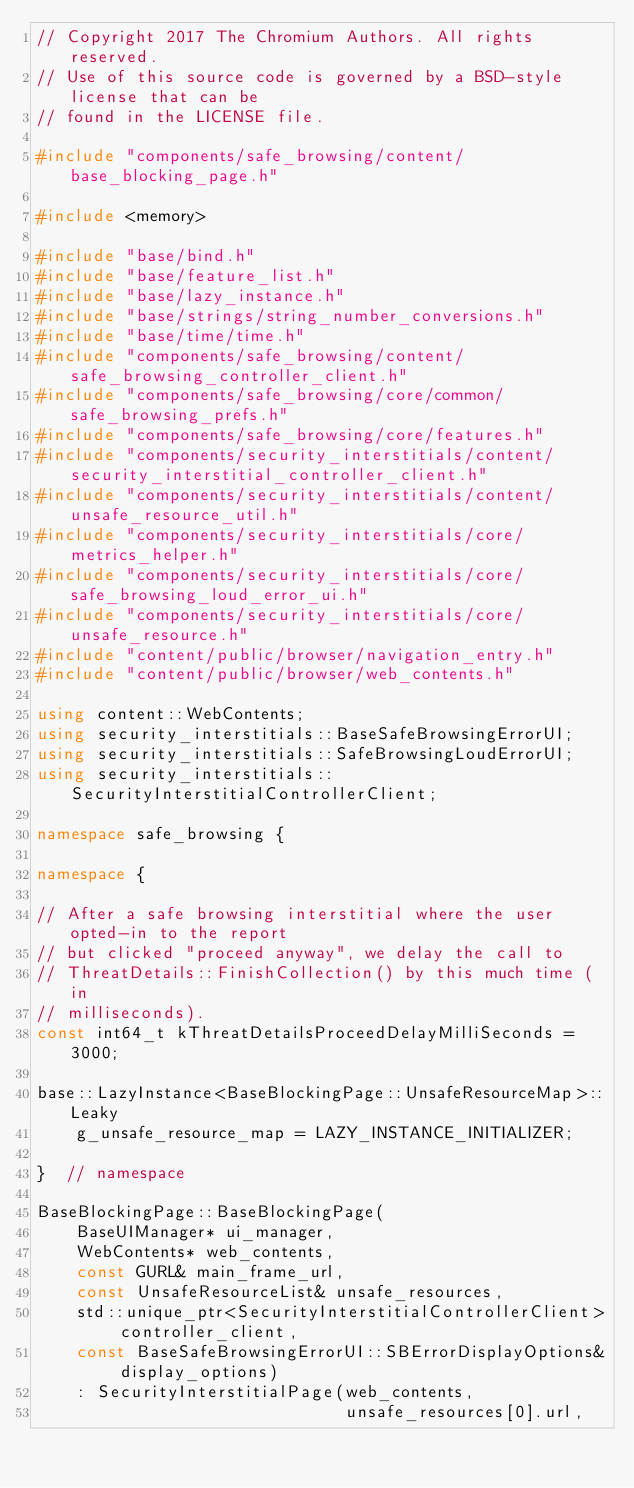Convert code to text. <code><loc_0><loc_0><loc_500><loc_500><_C++_>// Copyright 2017 The Chromium Authors. All rights reserved.
// Use of this source code is governed by a BSD-style license that can be
// found in the LICENSE file.

#include "components/safe_browsing/content/base_blocking_page.h"

#include <memory>

#include "base/bind.h"
#include "base/feature_list.h"
#include "base/lazy_instance.h"
#include "base/strings/string_number_conversions.h"
#include "base/time/time.h"
#include "components/safe_browsing/content/safe_browsing_controller_client.h"
#include "components/safe_browsing/core/common/safe_browsing_prefs.h"
#include "components/safe_browsing/core/features.h"
#include "components/security_interstitials/content/security_interstitial_controller_client.h"
#include "components/security_interstitials/content/unsafe_resource_util.h"
#include "components/security_interstitials/core/metrics_helper.h"
#include "components/security_interstitials/core/safe_browsing_loud_error_ui.h"
#include "components/security_interstitials/core/unsafe_resource.h"
#include "content/public/browser/navigation_entry.h"
#include "content/public/browser/web_contents.h"

using content::WebContents;
using security_interstitials::BaseSafeBrowsingErrorUI;
using security_interstitials::SafeBrowsingLoudErrorUI;
using security_interstitials::SecurityInterstitialControllerClient;

namespace safe_browsing {

namespace {

// After a safe browsing interstitial where the user opted-in to the report
// but clicked "proceed anyway", we delay the call to
// ThreatDetails::FinishCollection() by this much time (in
// milliseconds).
const int64_t kThreatDetailsProceedDelayMilliSeconds = 3000;

base::LazyInstance<BaseBlockingPage::UnsafeResourceMap>::Leaky
    g_unsafe_resource_map = LAZY_INSTANCE_INITIALIZER;

}  // namespace

BaseBlockingPage::BaseBlockingPage(
    BaseUIManager* ui_manager,
    WebContents* web_contents,
    const GURL& main_frame_url,
    const UnsafeResourceList& unsafe_resources,
    std::unique_ptr<SecurityInterstitialControllerClient> controller_client,
    const BaseSafeBrowsingErrorUI::SBErrorDisplayOptions& display_options)
    : SecurityInterstitialPage(web_contents,
                               unsafe_resources[0].url,</code> 